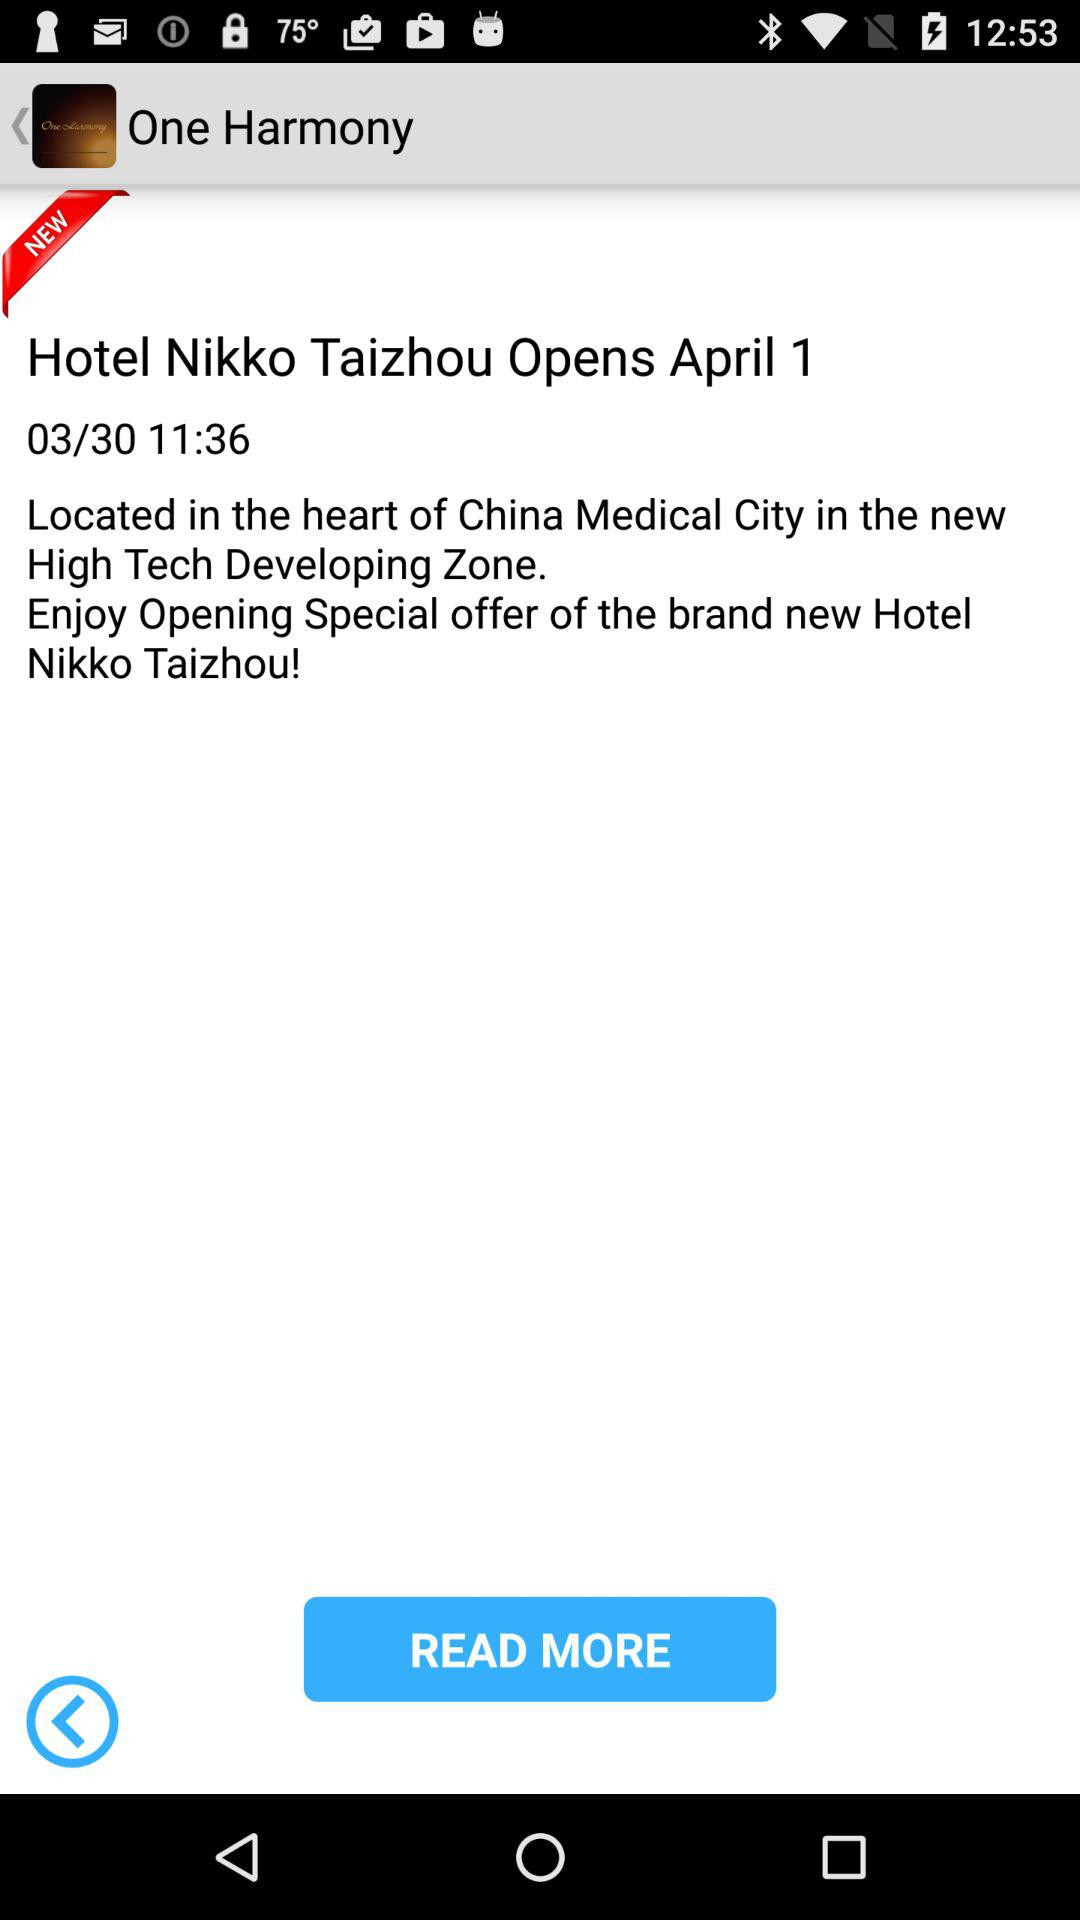When will the "Hotel Nikko Taizhou" open? The "Hotel Nikko Taizhou" will open on April 1. 